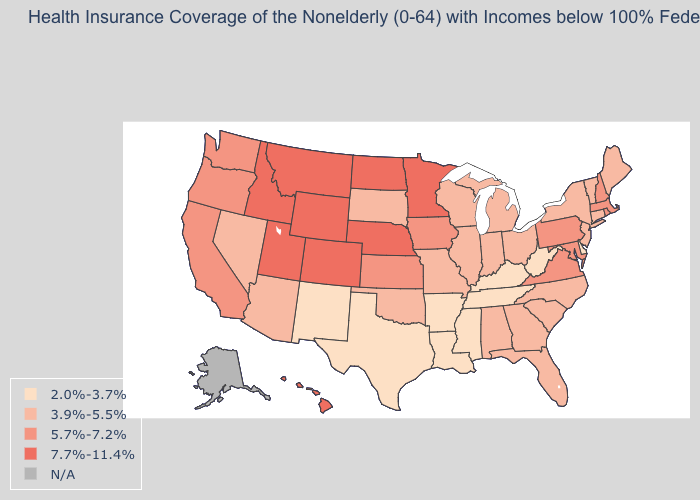What is the highest value in states that border Kansas?
Concise answer only. 7.7%-11.4%. Which states have the highest value in the USA?
Concise answer only. Colorado, Hawaii, Idaho, Minnesota, Montana, Nebraska, North Dakota, Utah, Wyoming. What is the value of New York?
Quick response, please. 3.9%-5.5%. Which states have the lowest value in the West?
Concise answer only. New Mexico. Name the states that have a value in the range N/A?
Be succinct. Alaska. What is the value of Idaho?
Give a very brief answer. 7.7%-11.4%. Does Colorado have the highest value in the USA?
Keep it brief. Yes. Which states have the highest value in the USA?
Be succinct. Colorado, Hawaii, Idaho, Minnesota, Montana, Nebraska, North Dakota, Utah, Wyoming. Which states have the lowest value in the USA?
Keep it brief. Arkansas, Delaware, Kentucky, Louisiana, Mississippi, New Mexico, Tennessee, Texas, West Virginia. Name the states that have a value in the range 7.7%-11.4%?
Write a very short answer. Colorado, Hawaii, Idaho, Minnesota, Montana, Nebraska, North Dakota, Utah, Wyoming. What is the value of Idaho?
Answer briefly. 7.7%-11.4%. Name the states that have a value in the range 7.7%-11.4%?
Quick response, please. Colorado, Hawaii, Idaho, Minnesota, Montana, Nebraska, North Dakota, Utah, Wyoming. Name the states that have a value in the range 5.7%-7.2%?
Keep it brief. California, Iowa, Kansas, Maryland, Massachusetts, New Hampshire, Oregon, Pennsylvania, Rhode Island, Virginia, Washington. Which states have the highest value in the USA?
Short answer required. Colorado, Hawaii, Idaho, Minnesota, Montana, Nebraska, North Dakota, Utah, Wyoming. 